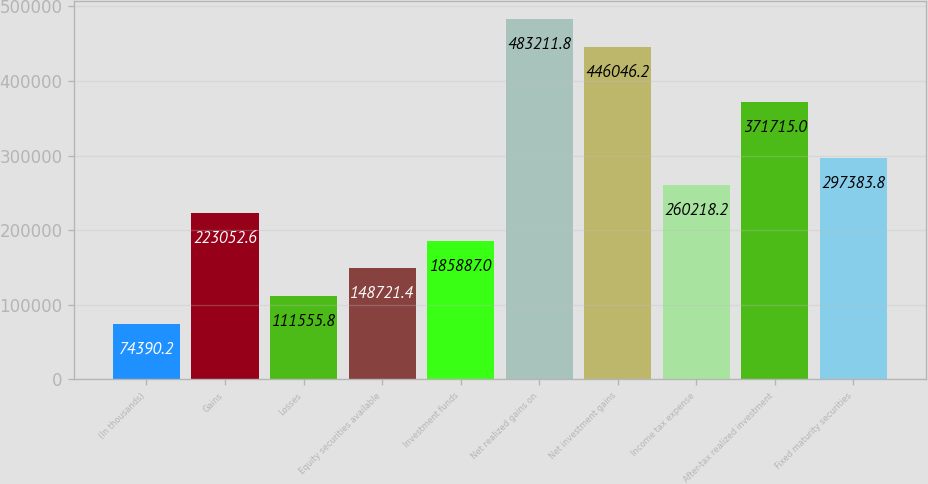Convert chart to OTSL. <chart><loc_0><loc_0><loc_500><loc_500><bar_chart><fcel>(In thousands)<fcel>Gains<fcel>Losses<fcel>Equity securities available<fcel>Investment funds<fcel>Net realized gains on<fcel>Net investment gains<fcel>Income tax expense<fcel>After-tax realized investment<fcel>Fixed maturity securities<nl><fcel>74390.2<fcel>223053<fcel>111556<fcel>148721<fcel>185887<fcel>483212<fcel>446046<fcel>260218<fcel>371715<fcel>297384<nl></chart> 